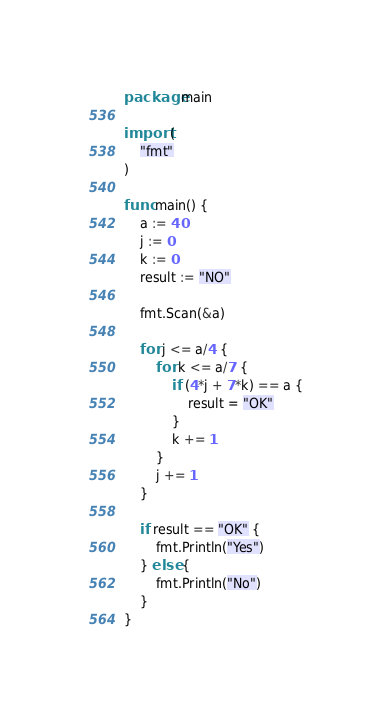<code> <loc_0><loc_0><loc_500><loc_500><_Go_>package main

import (
	"fmt"
)

func main() {
	a := 40
	j := 0
	k := 0
	result := "NO"

	fmt.Scan(&a)

	for j <= a/4 {
		for k <= a/7 {
			if (4*j + 7*k) == a {
				result = "OK"
			}
			k += 1
		}
		j += 1
	}

	if result == "OK" {
		fmt.Println("Yes")
	} else {
		fmt.Println("No")
	}
}
</code> 